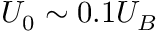Convert formula to latex. <formula><loc_0><loc_0><loc_500><loc_500>U _ { 0 } \sim 0 . 1 U _ { B }</formula> 